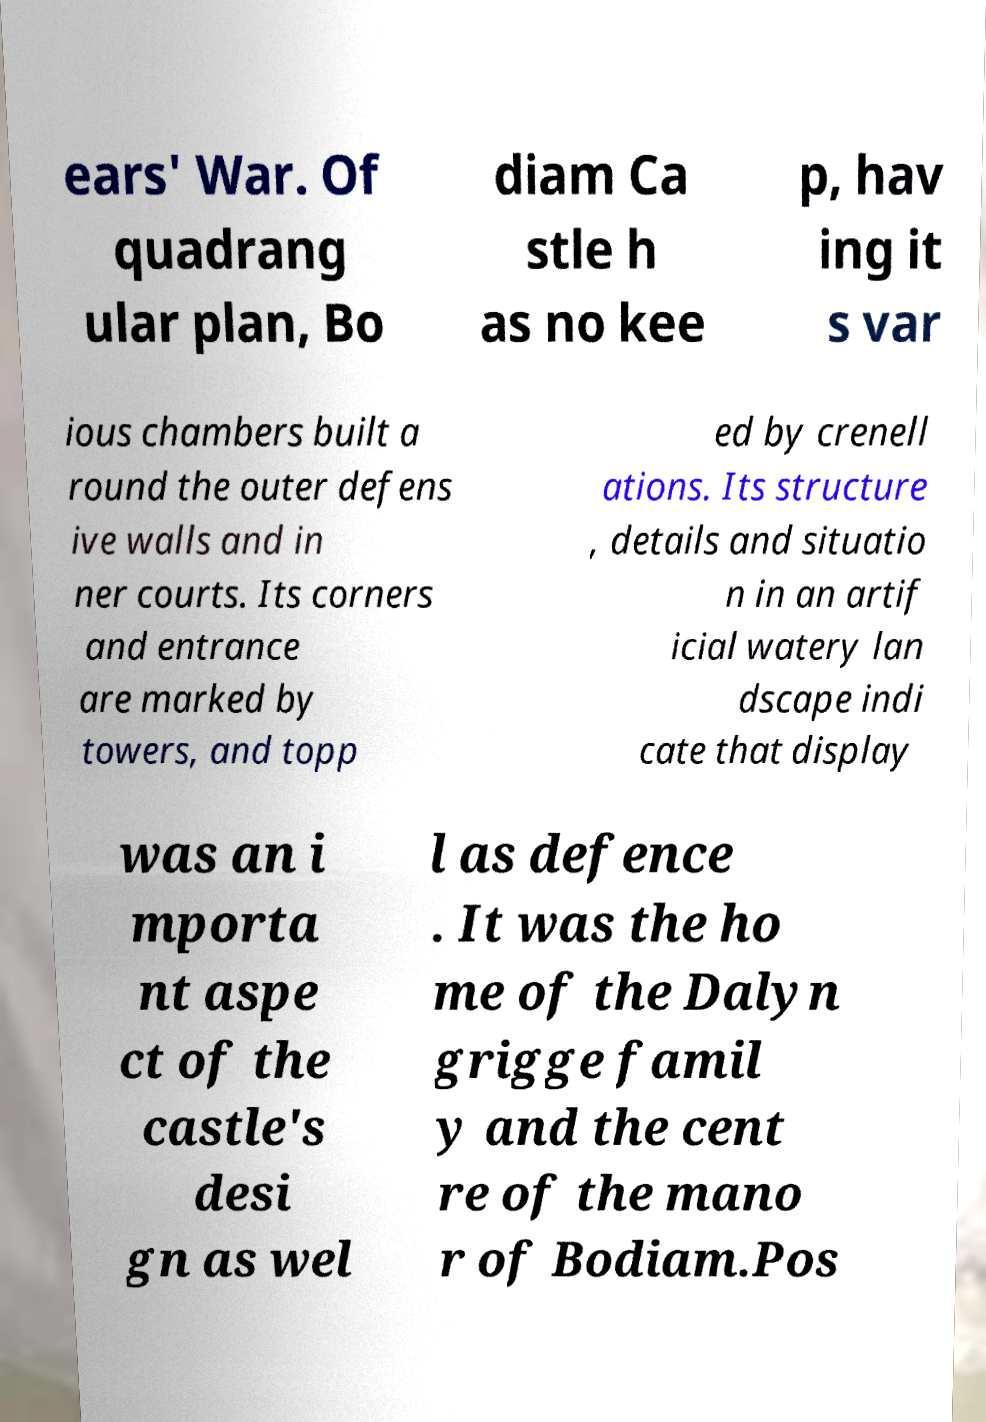There's text embedded in this image that I need extracted. Can you transcribe it verbatim? ears' War. Of quadrang ular plan, Bo diam Ca stle h as no kee p, hav ing it s var ious chambers built a round the outer defens ive walls and in ner courts. Its corners and entrance are marked by towers, and topp ed by crenell ations. Its structure , details and situatio n in an artif icial watery lan dscape indi cate that display was an i mporta nt aspe ct of the castle's desi gn as wel l as defence . It was the ho me of the Dalyn grigge famil y and the cent re of the mano r of Bodiam.Pos 